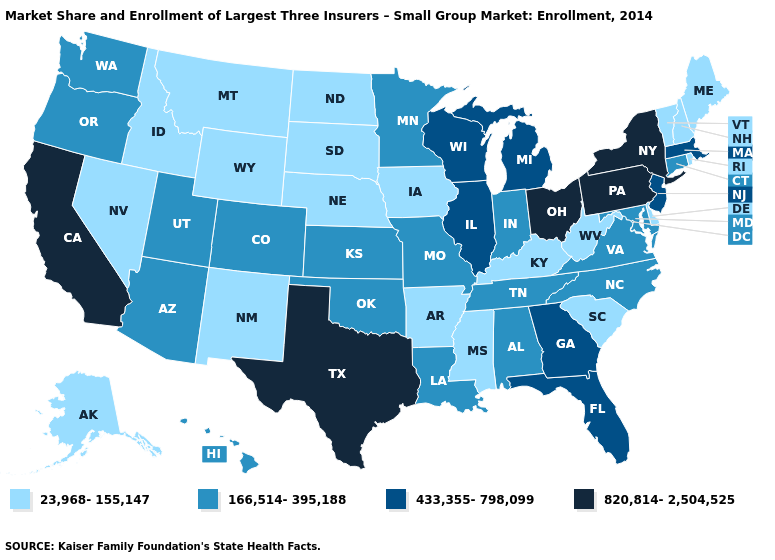Among the states that border South Carolina , which have the highest value?
Concise answer only. Georgia. Name the states that have a value in the range 433,355-798,099?
Quick response, please. Florida, Georgia, Illinois, Massachusetts, Michigan, New Jersey, Wisconsin. What is the value of Louisiana?
Be succinct. 166,514-395,188. Does the map have missing data?
Be succinct. No. Among the states that border Tennessee , which have the highest value?
Keep it brief. Georgia. What is the value of South Dakota?
Short answer required. 23,968-155,147. Does Colorado have the lowest value in the West?
Short answer required. No. Does South Dakota have the lowest value in the MidWest?
Write a very short answer. Yes. Does Colorado have a higher value than Vermont?
Short answer required. Yes. What is the value of Hawaii?
Quick response, please. 166,514-395,188. Which states have the lowest value in the Northeast?
Concise answer only. Maine, New Hampshire, Rhode Island, Vermont. Which states hav the highest value in the Northeast?
Answer briefly. New York, Pennsylvania. Among the states that border Delaware , which have the highest value?
Quick response, please. Pennsylvania. What is the value of North Carolina?
Concise answer only. 166,514-395,188. Does Colorado have the highest value in the West?
Be succinct. No. 